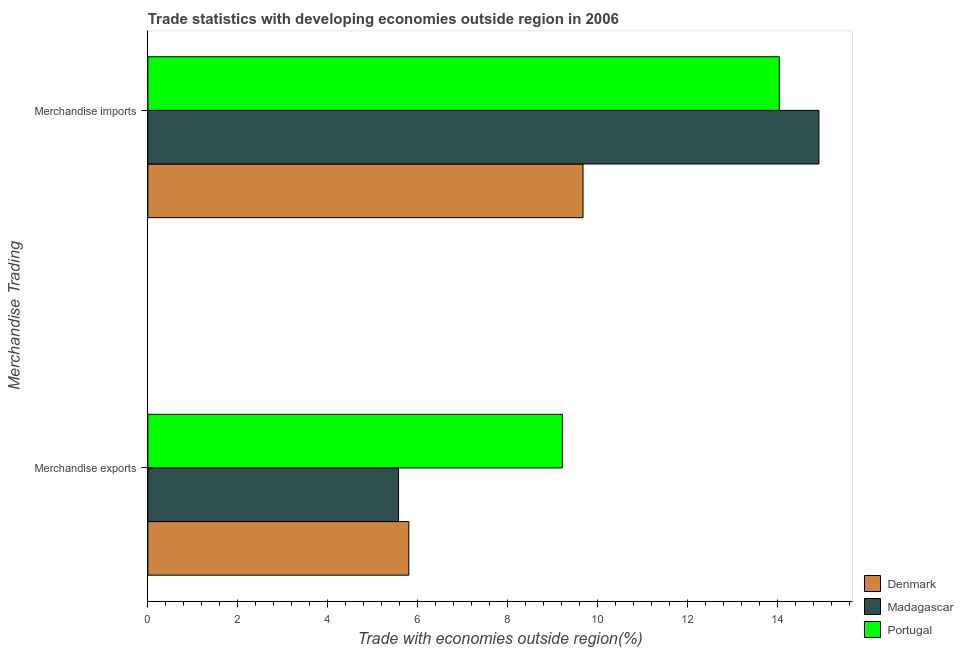Are the number of bars per tick equal to the number of legend labels?
Keep it short and to the point. Yes. What is the label of the 2nd group of bars from the top?
Provide a short and direct response. Merchandise exports. What is the merchandise exports in Madagascar?
Keep it short and to the point. 5.58. Across all countries, what is the maximum merchandise exports?
Ensure brevity in your answer.  9.22. Across all countries, what is the minimum merchandise imports?
Make the answer very short. 9.68. In which country was the merchandise imports maximum?
Provide a short and direct response. Madagascar. In which country was the merchandise exports minimum?
Provide a succinct answer. Madagascar. What is the total merchandise imports in the graph?
Your answer should be compact. 38.66. What is the difference between the merchandise exports in Denmark and that in Madagascar?
Ensure brevity in your answer.  0.23. What is the difference between the merchandise exports in Portugal and the merchandise imports in Madagascar?
Your answer should be compact. -5.71. What is the average merchandise imports per country?
Ensure brevity in your answer.  12.89. What is the difference between the merchandise imports and merchandise exports in Portugal?
Your answer should be very brief. 4.83. In how many countries, is the merchandise imports greater than 12.4 %?
Give a very brief answer. 2. What is the ratio of the merchandise imports in Portugal to that in Madagascar?
Your answer should be compact. 0.94. What does the 2nd bar from the top in Merchandise exports represents?
Your response must be concise. Madagascar. What does the 1st bar from the bottom in Merchandise imports represents?
Give a very brief answer. Denmark. How many bars are there?
Your answer should be compact. 6. What is the difference between two consecutive major ticks on the X-axis?
Offer a very short reply. 2. Does the graph contain any zero values?
Keep it short and to the point. No. Does the graph contain grids?
Offer a terse response. No. How many legend labels are there?
Provide a short and direct response. 3. How are the legend labels stacked?
Keep it short and to the point. Vertical. What is the title of the graph?
Provide a short and direct response. Trade statistics with developing economies outside region in 2006. Does "Lebanon" appear as one of the legend labels in the graph?
Ensure brevity in your answer.  No. What is the label or title of the X-axis?
Make the answer very short. Trade with economies outside region(%). What is the label or title of the Y-axis?
Ensure brevity in your answer.  Merchandise Trading. What is the Trade with economies outside region(%) in Denmark in Merchandise exports?
Your response must be concise. 5.81. What is the Trade with economies outside region(%) of Madagascar in Merchandise exports?
Provide a short and direct response. 5.58. What is the Trade with economies outside region(%) in Portugal in Merchandise exports?
Your answer should be compact. 9.22. What is the Trade with economies outside region(%) of Denmark in Merchandise imports?
Your answer should be compact. 9.68. What is the Trade with economies outside region(%) in Madagascar in Merchandise imports?
Provide a short and direct response. 14.93. What is the Trade with economies outside region(%) of Portugal in Merchandise imports?
Provide a short and direct response. 14.05. Across all Merchandise Trading, what is the maximum Trade with economies outside region(%) in Denmark?
Make the answer very short. 9.68. Across all Merchandise Trading, what is the maximum Trade with economies outside region(%) in Madagascar?
Your answer should be compact. 14.93. Across all Merchandise Trading, what is the maximum Trade with economies outside region(%) of Portugal?
Your response must be concise. 14.05. Across all Merchandise Trading, what is the minimum Trade with economies outside region(%) in Denmark?
Offer a terse response. 5.81. Across all Merchandise Trading, what is the minimum Trade with economies outside region(%) in Madagascar?
Offer a very short reply. 5.58. Across all Merchandise Trading, what is the minimum Trade with economies outside region(%) in Portugal?
Make the answer very short. 9.22. What is the total Trade with economies outside region(%) of Denmark in the graph?
Offer a very short reply. 15.49. What is the total Trade with economies outside region(%) of Madagascar in the graph?
Your response must be concise. 20.51. What is the total Trade with economies outside region(%) of Portugal in the graph?
Your response must be concise. 23.27. What is the difference between the Trade with economies outside region(%) in Denmark in Merchandise exports and that in Merchandise imports?
Your response must be concise. -3.88. What is the difference between the Trade with economies outside region(%) of Madagascar in Merchandise exports and that in Merchandise imports?
Make the answer very short. -9.35. What is the difference between the Trade with economies outside region(%) of Portugal in Merchandise exports and that in Merchandise imports?
Provide a succinct answer. -4.83. What is the difference between the Trade with economies outside region(%) in Denmark in Merchandise exports and the Trade with economies outside region(%) in Madagascar in Merchandise imports?
Offer a very short reply. -9.12. What is the difference between the Trade with economies outside region(%) in Denmark in Merchandise exports and the Trade with economies outside region(%) in Portugal in Merchandise imports?
Your answer should be compact. -8.24. What is the difference between the Trade with economies outside region(%) in Madagascar in Merchandise exports and the Trade with economies outside region(%) in Portugal in Merchandise imports?
Your answer should be very brief. -8.47. What is the average Trade with economies outside region(%) of Denmark per Merchandise Trading?
Your response must be concise. 7.74. What is the average Trade with economies outside region(%) of Madagascar per Merchandise Trading?
Give a very brief answer. 10.25. What is the average Trade with economies outside region(%) of Portugal per Merchandise Trading?
Provide a short and direct response. 11.63. What is the difference between the Trade with economies outside region(%) of Denmark and Trade with economies outside region(%) of Madagascar in Merchandise exports?
Provide a short and direct response. 0.23. What is the difference between the Trade with economies outside region(%) of Denmark and Trade with economies outside region(%) of Portugal in Merchandise exports?
Give a very brief answer. -3.42. What is the difference between the Trade with economies outside region(%) of Madagascar and Trade with economies outside region(%) of Portugal in Merchandise exports?
Provide a short and direct response. -3.64. What is the difference between the Trade with economies outside region(%) of Denmark and Trade with economies outside region(%) of Madagascar in Merchandise imports?
Your response must be concise. -5.25. What is the difference between the Trade with economies outside region(%) of Denmark and Trade with economies outside region(%) of Portugal in Merchandise imports?
Give a very brief answer. -4.37. What is the difference between the Trade with economies outside region(%) in Madagascar and Trade with economies outside region(%) in Portugal in Merchandise imports?
Provide a short and direct response. 0.88. What is the ratio of the Trade with economies outside region(%) in Denmark in Merchandise exports to that in Merchandise imports?
Make the answer very short. 0.6. What is the ratio of the Trade with economies outside region(%) in Madagascar in Merchandise exports to that in Merchandise imports?
Your response must be concise. 0.37. What is the ratio of the Trade with economies outside region(%) in Portugal in Merchandise exports to that in Merchandise imports?
Offer a terse response. 0.66. What is the difference between the highest and the second highest Trade with economies outside region(%) of Denmark?
Offer a very short reply. 3.88. What is the difference between the highest and the second highest Trade with economies outside region(%) in Madagascar?
Provide a succinct answer. 9.35. What is the difference between the highest and the second highest Trade with economies outside region(%) in Portugal?
Offer a terse response. 4.83. What is the difference between the highest and the lowest Trade with economies outside region(%) of Denmark?
Provide a short and direct response. 3.88. What is the difference between the highest and the lowest Trade with economies outside region(%) of Madagascar?
Offer a terse response. 9.35. What is the difference between the highest and the lowest Trade with economies outside region(%) in Portugal?
Give a very brief answer. 4.83. 